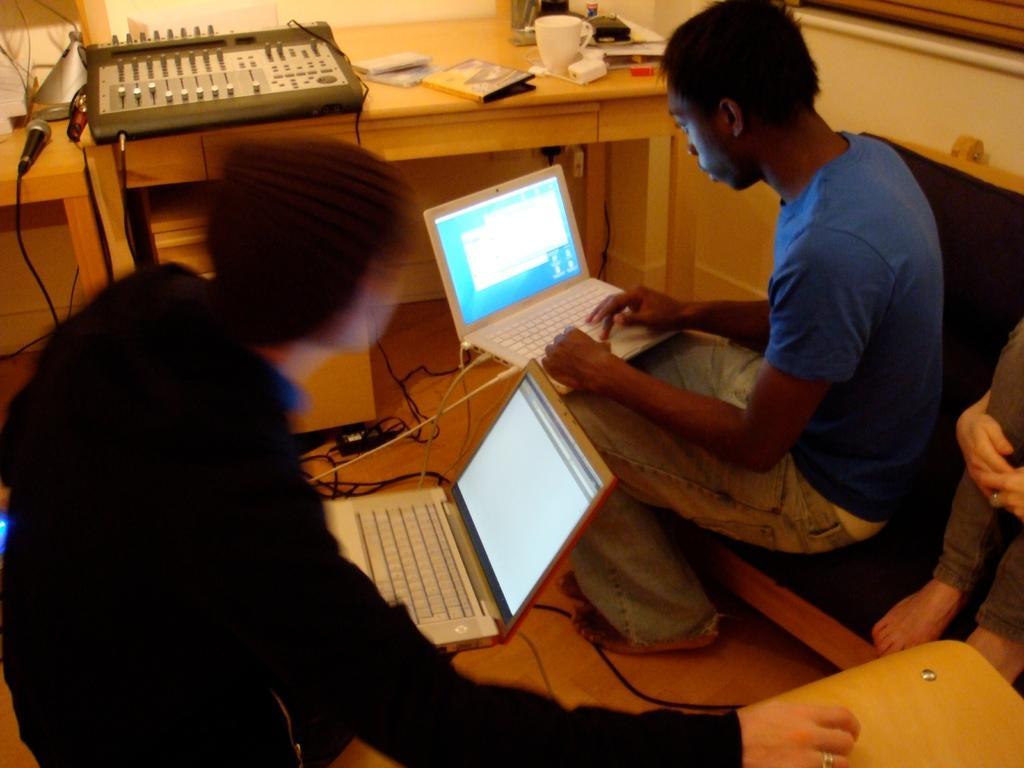In one or two sentences, can you explain what this image depicts? In this image there are three persons sitting on a sofa. In the right side there is a man, he is wearing a blue t shirt, cream jeans and he is working on a laptop, behind him there is another person sitting on a sofa. Towards the left there is a man he is wearing a black t shirt and brown cap. In the background there is a table. On the table there is a machine, book, mike, cup and etc. 